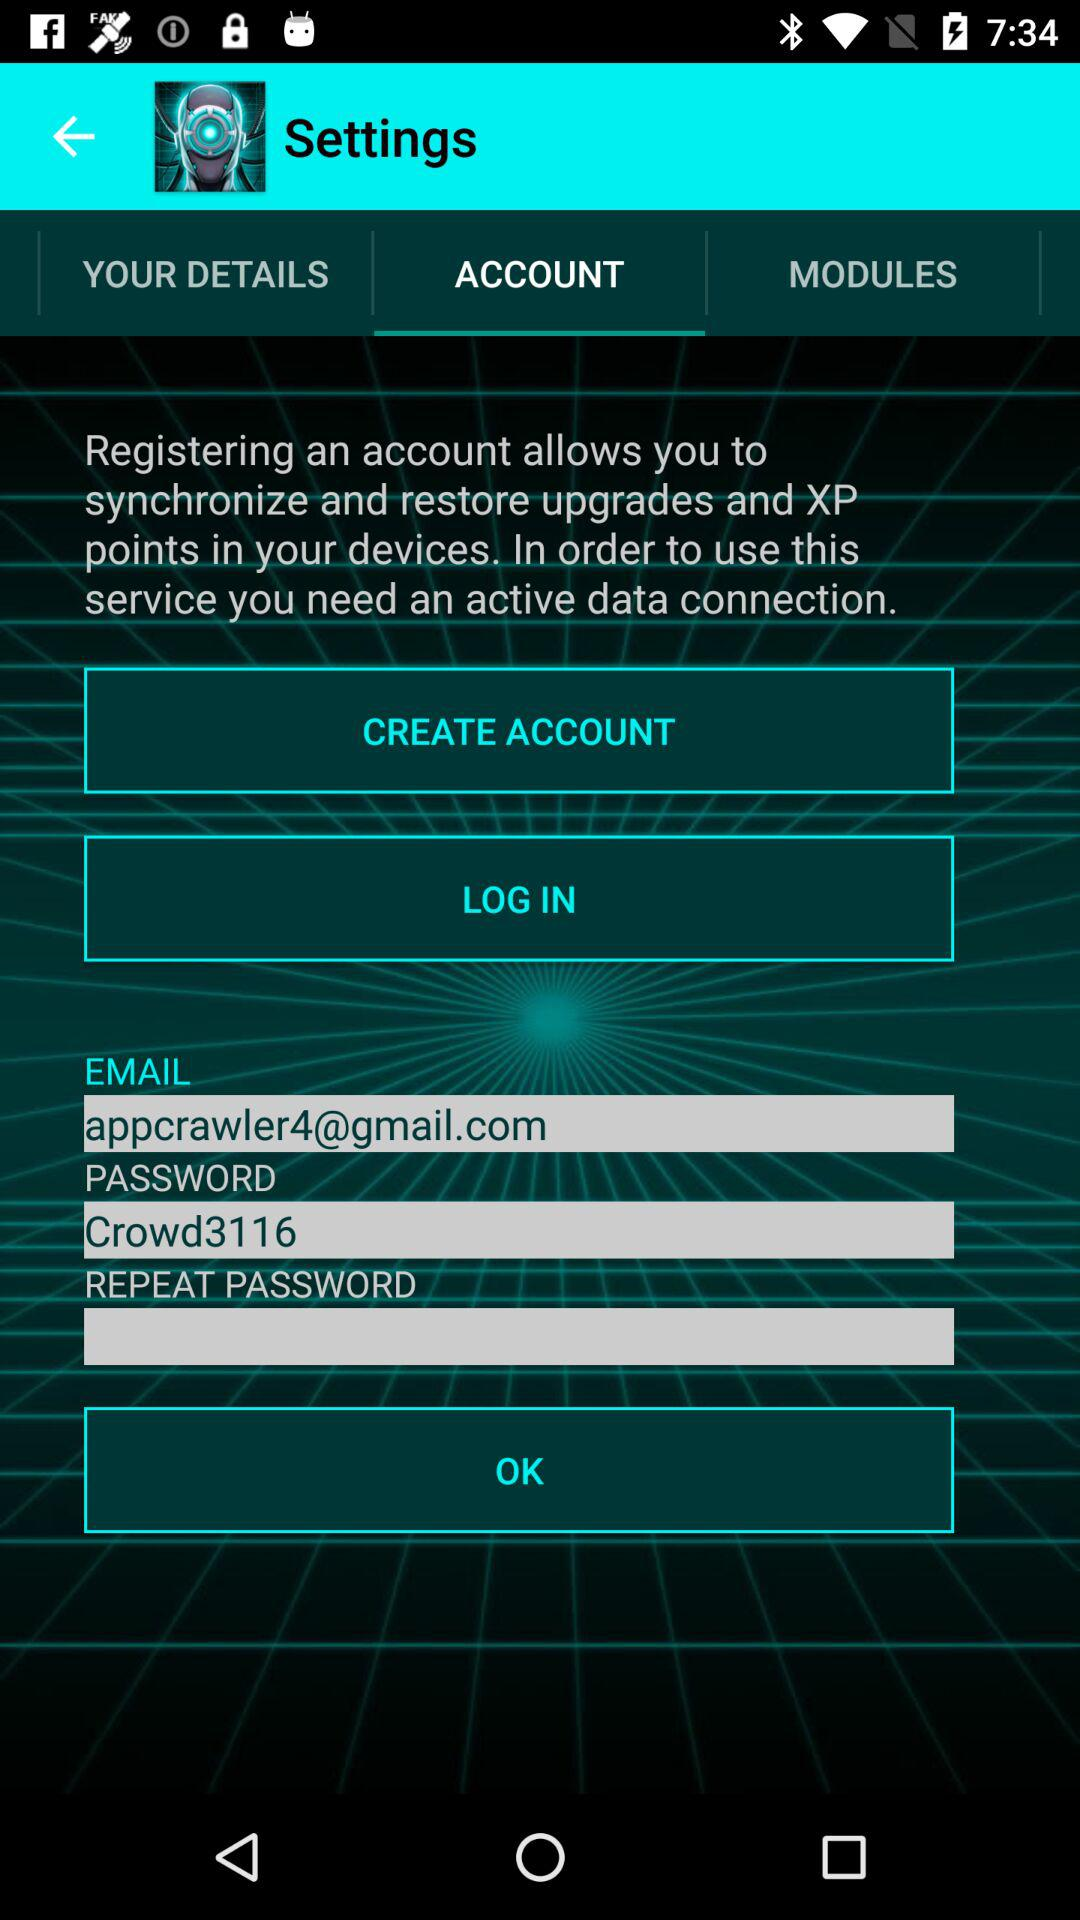What Gmail address is used? The used Gmail address is appcrawler4@gmail.com. 